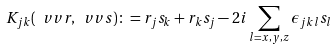Convert formula to latex. <formula><loc_0><loc_0><loc_500><loc_500>K _ { j k } ( \ v v { r } , \ v v { s } ) \colon = r _ { j } s _ { k } + r _ { k } s _ { j } - 2 i \sum _ { l = x , y , z } \epsilon _ { j k l } s _ { l }</formula> 